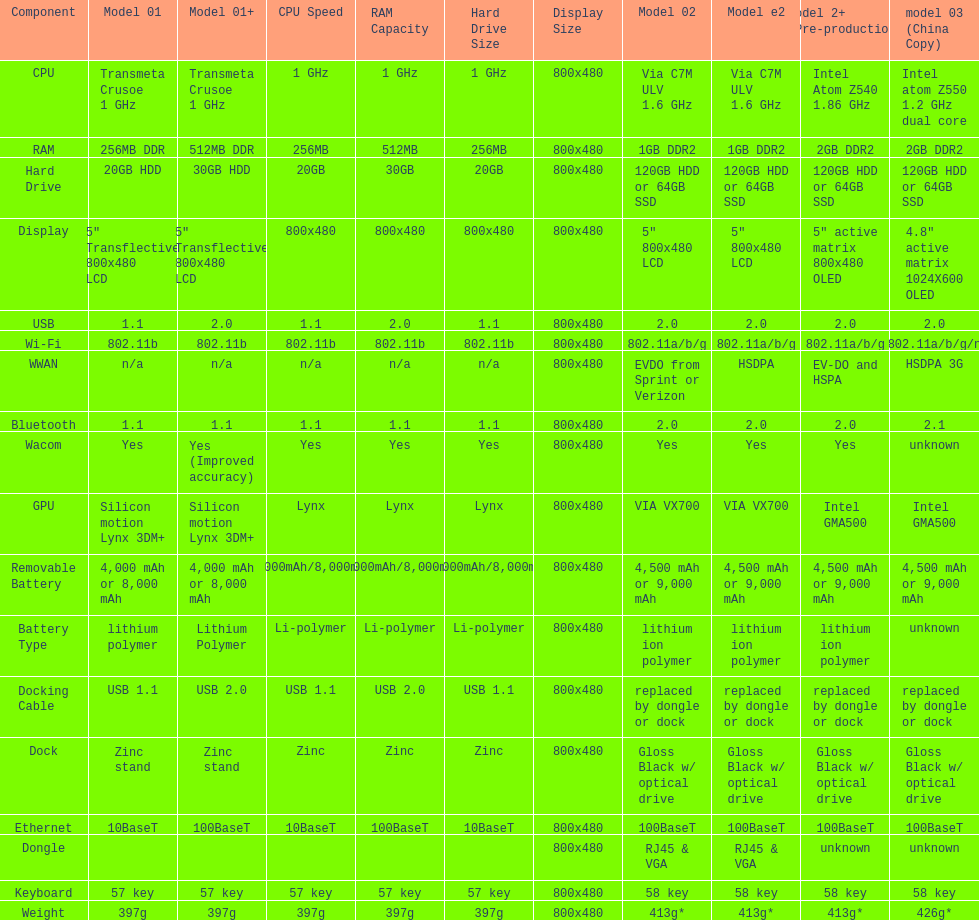How many devices feature a 2. 